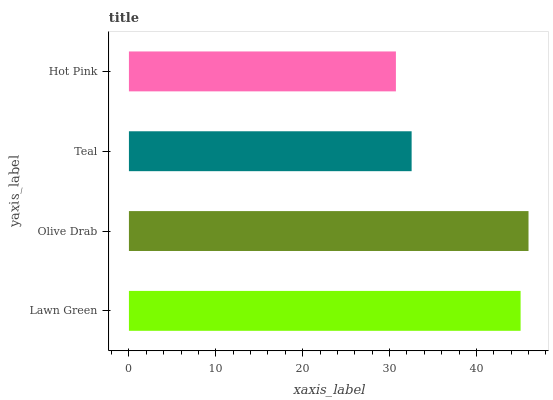Is Hot Pink the minimum?
Answer yes or no. Yes. Is Olive Drab the maximum?
Answer yes or no. Yes. Is Teal the minimum?
Answer yes or no. No. Is Teal the maximum?
Answer yes or no. No. Is Olive Drab greater than Teal?
Answer yes or no. Yes. Is Teal less than Olive Drab?
Answer yes or no. Yes. Is Teal greater than Olive Drab?
Answer yes or no. No. Is Olive Drab less than Teal?
Answer yes or no. No. Is Lawn Green the high median?
Answer yes or no. Yes. Is Teal the low median?
Answer yes or no. Yes. Is Teal the high median?
Answer yes or no. No. Is Olive Drab the low median?
Answer yes or no. No. 